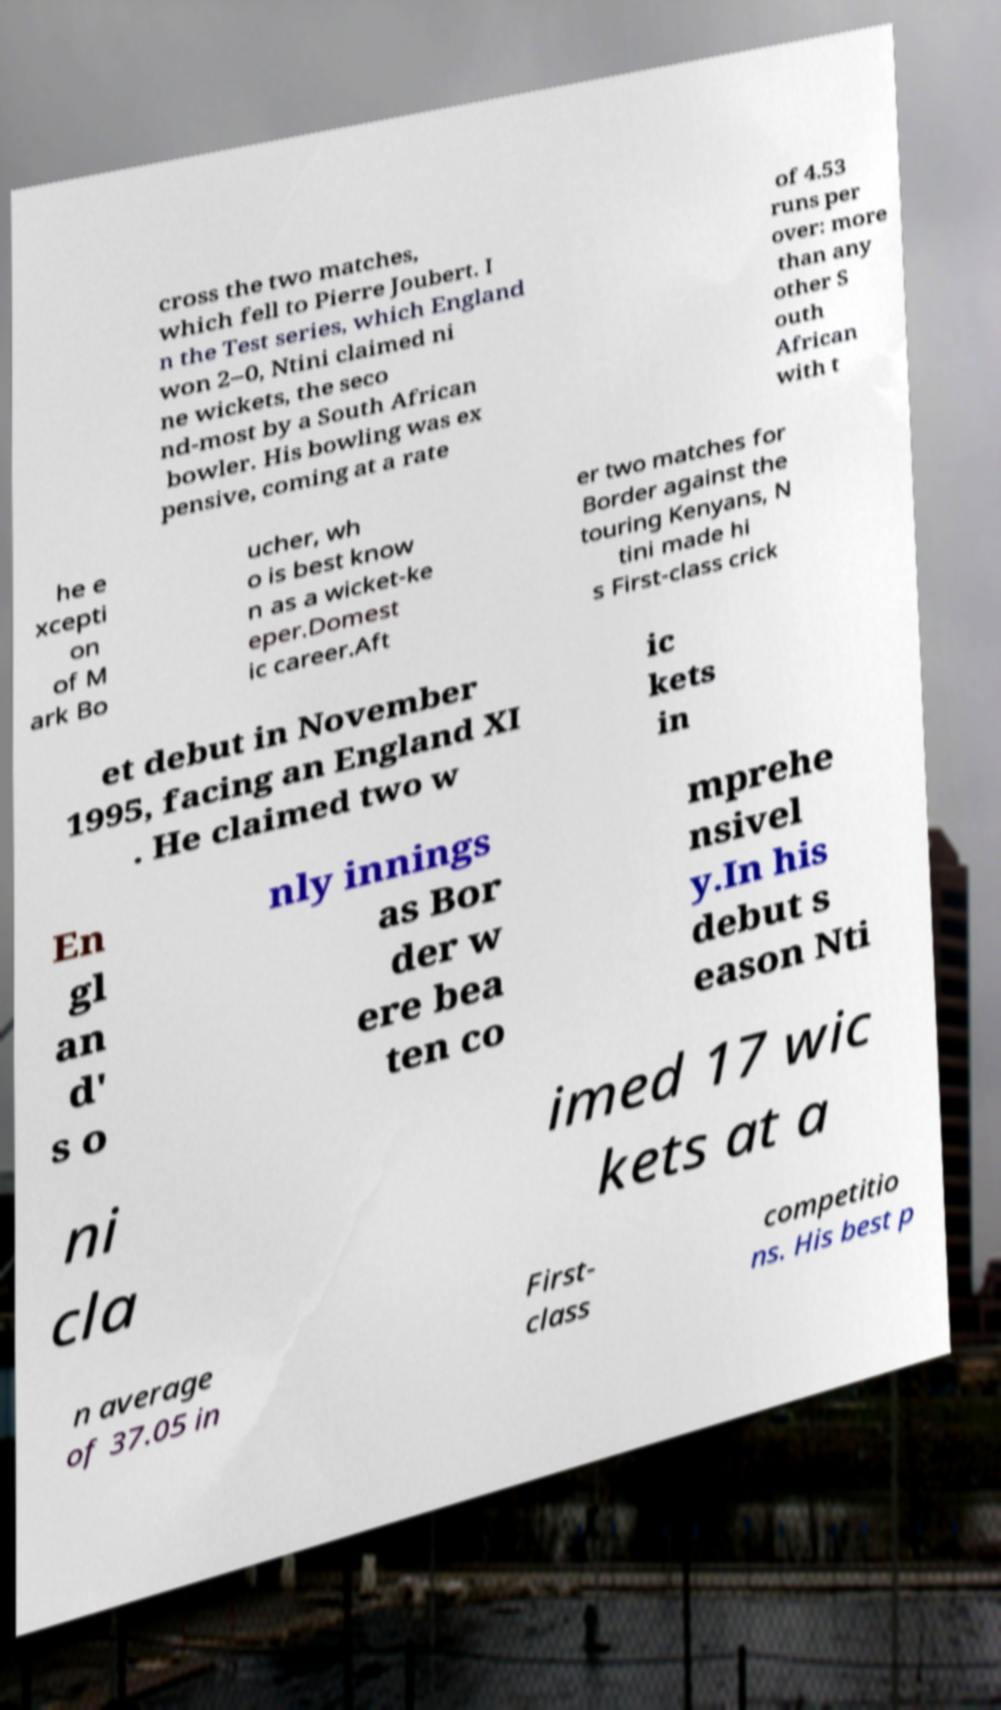Could you extract and type out the text from this image? cross the two matches, which fell to Pierre Joubert. I n the Test series, which England won 2–0, Ntini claimed ni ne wickets, the seco nd-most by a South African bowler. His bowling was ex pensive, coming at a rate of 4.53 runs per over: more than any other S outh African with t he e xcepti on of M ark Bo ucher, wh o is best know n as a wicket-ke eper.Domest ic career.Aft er two matches for Border against the touring Kenyans, N tini made hi s First-class crick et debut in November 1995, facing an England XI . He claimed two w ic kets in En gl an d' s o nly innings as Bor der w ere bea ten co mprehe nsivel y.In his debut s eason Nti ni cla imed 17 wic kets at a n average of 37.05 in First- class competitio ns. His best p 